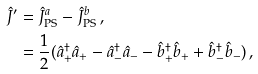<formula> <loc_0><loc_0><loc_500><loc_500>\hat { J } ^ { \prime } & = \hat { J } _ { \text {PS} } ^ { a } - \hat { J } _ { \text {PS} } ^ { b } \, , \\ & = \frac { 1 } { 2 } ( \hat { a } _ { + } ^ { \dagger } \hat { a } _ { + } - \hat { a } _ { - } ^ { \dagger } \hat { a } _ { - } - \hat { b } _ { + } ^ { \dagger } \hat { b } _ { + } + \hat { b } _ { - } ^ { \dagger } \hat { b } _ { - } ) \, ,</formula> 